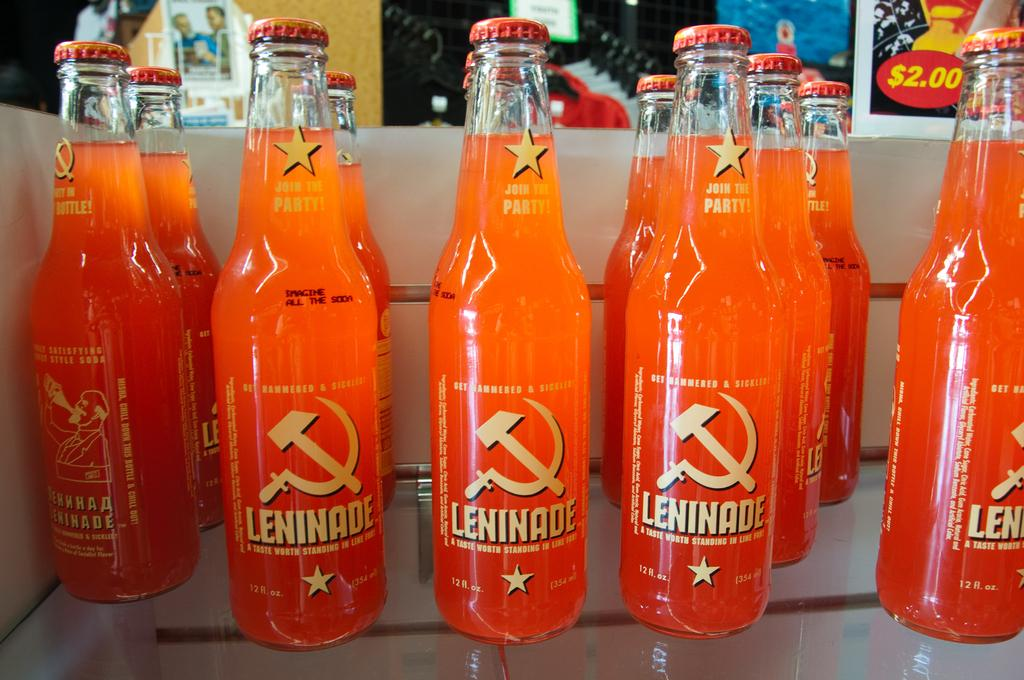Provide a one-sentence caption for the provided image. Several lines of clear glass bottles with orange Leninade, with a hammer and sickle logo on the label and yellow text. 